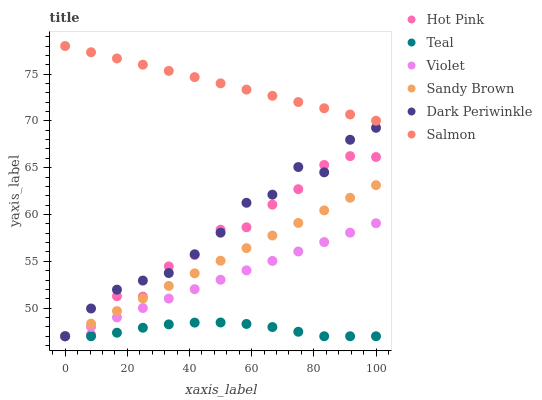Does Teal have the minimum area under the curve?
Answer yes or no. Yes. Does Salmon have the maximum area under the curve?
Answer yes or no. Yes. Does Salmon have the minimum area under the curve?
Answer yes or no. No. Does Teal have the maximum area under the curve?
Answer yes or no. No. Is Violet the smoothest?
Answer yes or no. Yes. Is Hot Pink the roughest?
Answer yes or no. Yes. Is Salmon the smoothest?
Answer yes or no. No. Is Salmon the roughest?
Answer yes or no. No. Does Hot Pink have the lowest value?
Answer yes or no. Yes. Does Salmon have the lowest value?
Answer yes or no. No. Does Salmon have the highest value?
Answer yes or no. Yes. Does Teal have the highest value?
Answer yes or no. No. Is Violet less than Salmon?
Answer yes or no. Yes. Is Salmon greater than Dark Periwinkle?
Answer yes or no. Yes. Does Sandy Brown intersect Dark Periwinkle?
Answer yes or no. Yes. Is Sandy Brown less than Dark Periwinkle?
Answer yes or no. No. Is Sandy Brown greater than Dark Periwinkle?
Answer yes or no. No. Does Violet intersect Salmon?
Answer yes or no. No. 